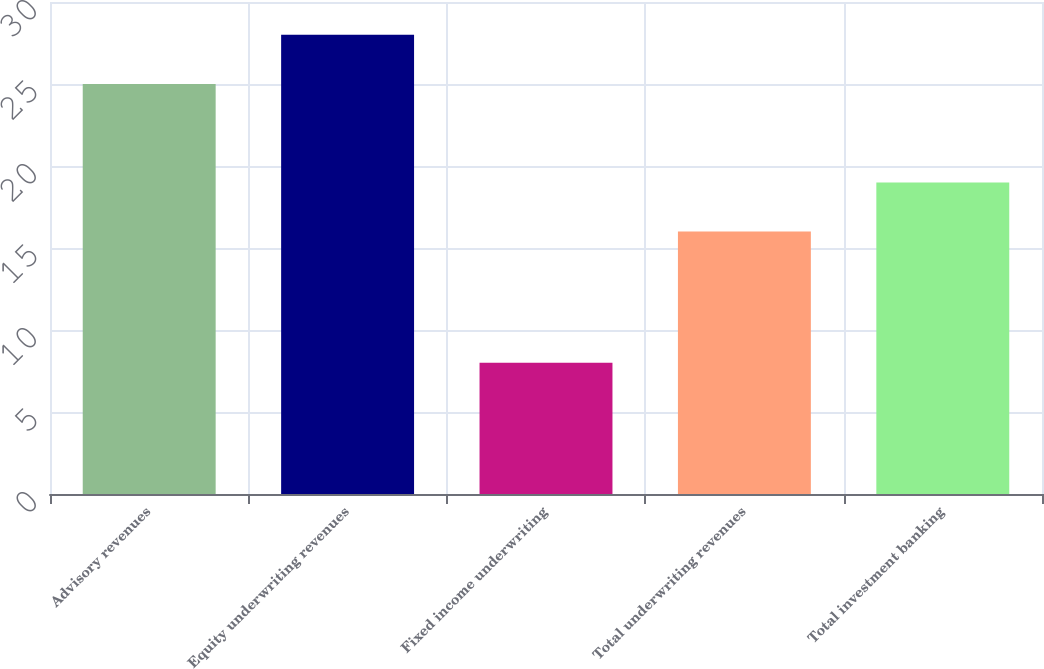<chart> <loc_0><loc_0><loc_500><loc_500><bar_chart><fcel>Advisory revenues<fcel>Equity underwriting revenues<fcel>Fixed income underwriting<fcel>Total underwriting revenues<fcel>Total investment banking<nl><fcel>25<fcel>28<fcel>8<fcel>16<fcel>19<nl></chart> 